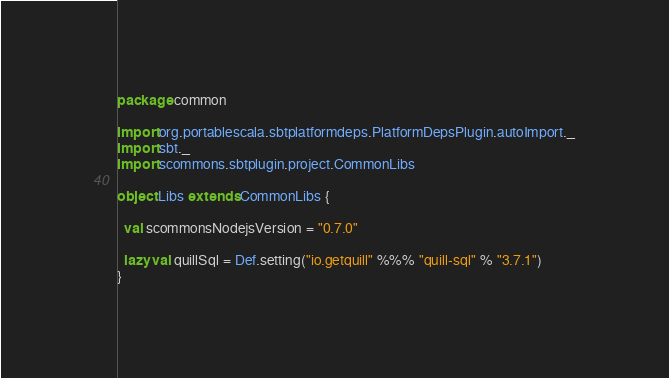<code> <loc_0><loc_0><loc_500><loc_500><_Scala_>package common

import org.portablescala.sbtplatformdeps.PlatformDepsPlugin.autoImport._
import sbt._
import scommons.sbtplugin.project.CommonLibs

object Libs extends CommonLibs {

  val scommonsNodejsVersion = "0.7.0"

  lazy val quillSql = Def.setting("io.getquill" %%% "quill-sql" % "3.7.1")
}
</code> 